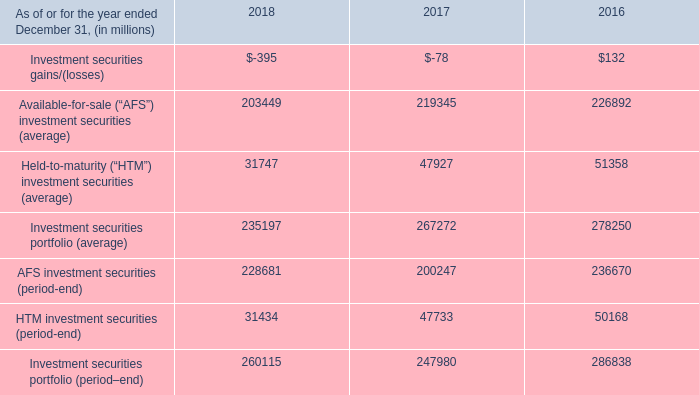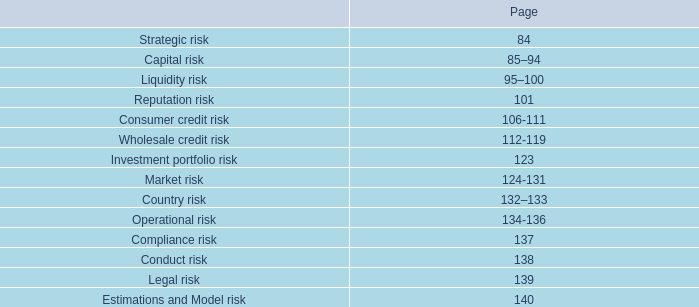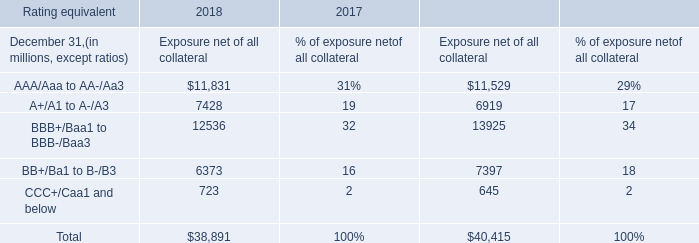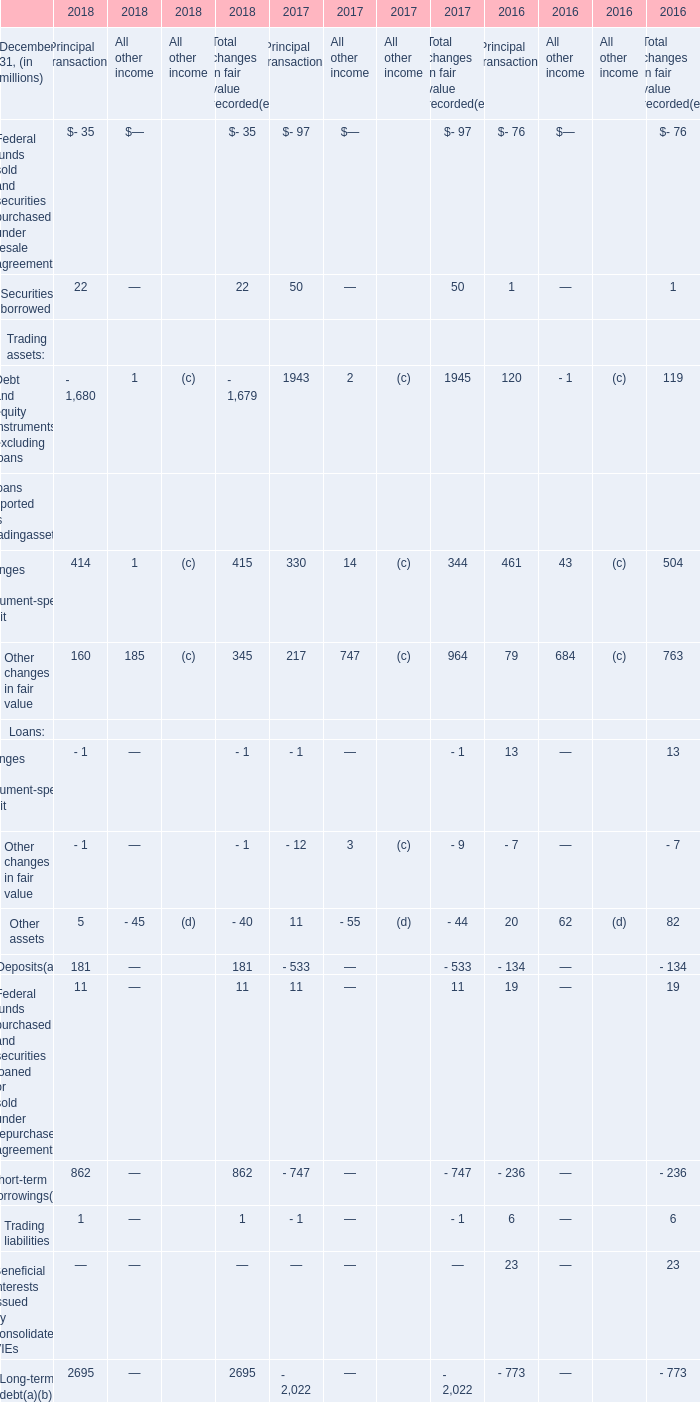As of December 31,what year is the Short-term borrowings for Principal transactions the lowest? 
Answer: 2017. 